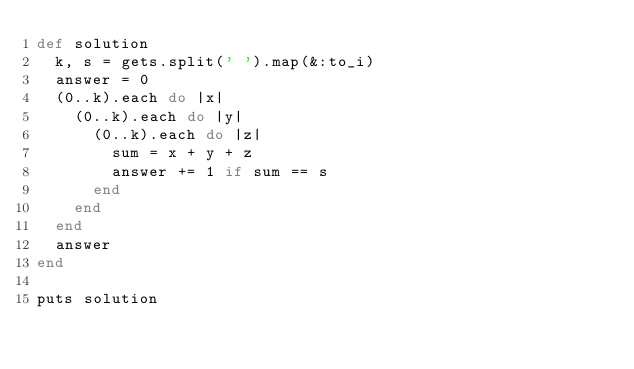<code> <loc_0><loc_0><loc_500><loc_500><_Ruby_>def solution
  k, s = gets.split(' ').map(&:to_i)
  answer = 0
  (0..k).each do |x|
    (0..k).each do |y|
      (0..k).each do |z|
        sum = x + y + z
        answer += 1 if sum == s
      end
    end
  end
  answer
end

puts solution
</code> 